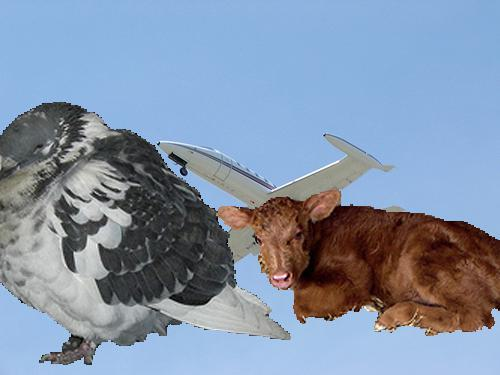Can you describe the setting of this image? The background of the image features a clear blue sky that seems to be a canvas for the juxtaposed elements of the bird-aeroplane hybrid and the calf, suggesting a surreal or dreamlike setting. Does the sky indicate anything about the time of day? The bright and uniform blue hue of the sky gives the impression of daytime, possibly morning or afternoon given the absence of shadows or a warm color palette that would suggest sunrise or sunset. 